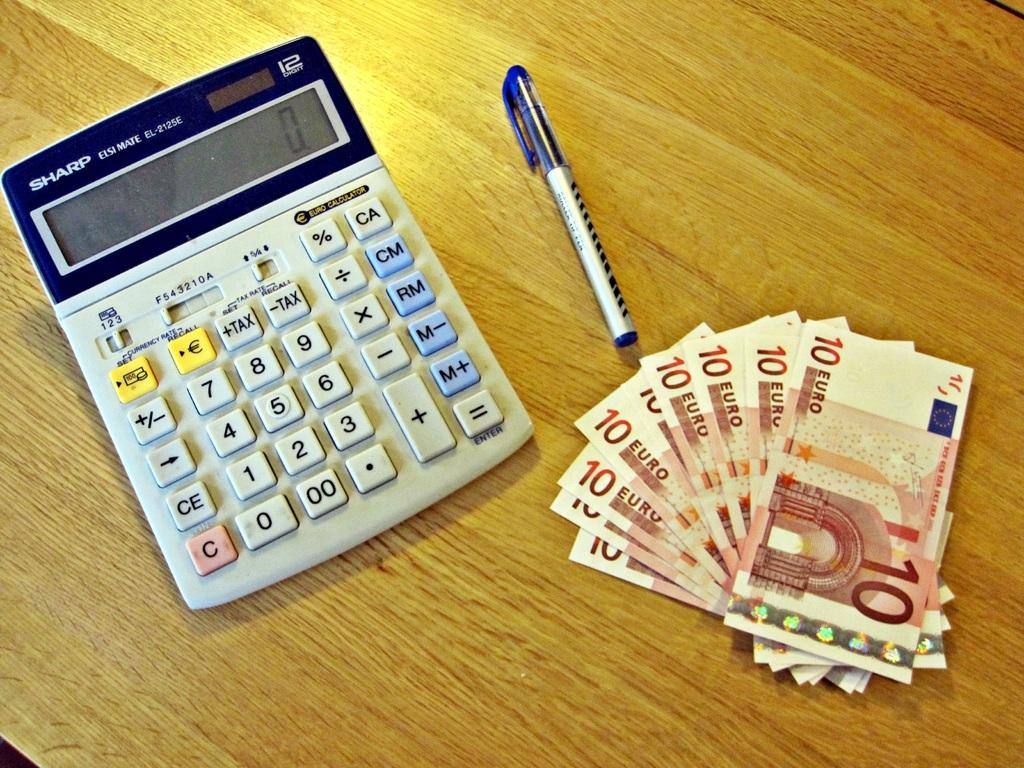Provide a one-sentence caption for the provided image. A calculator, pen and many euros labeled 10. 